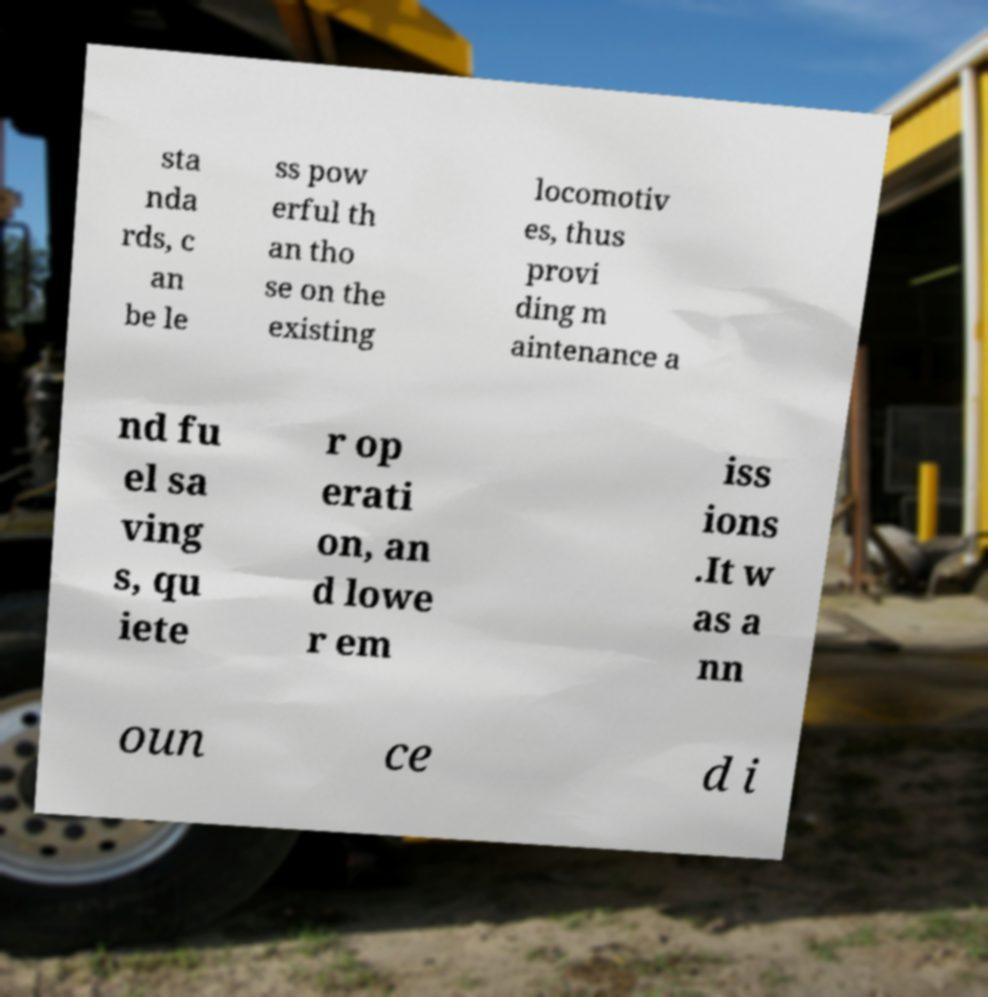What messages or text are displayed in this image? I need them in a readable, typed format. sta nda rds, c an be le ss pow erful th an tho se on the existing locomotiv es, thus provi ding m aintenance a nd fu el sa ving s, qu iete r op erati on, an d lowe r em iss ions .It w as a nn oun ce d i 